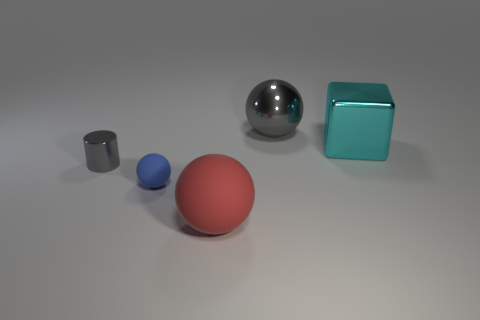The tiny shiny thing that is the same color as the large shiny sphere is what shape?
Your response must be concise. Cylinder. The tiny sphere is what color?
Your answer should be very brief. Blue. There is a gray metallic object on the left side of the red ball; how big is it?
Make the answer very short. Small. What number of cyan things are left of the large gray metallic ball that is to the right of the shiny cylinder to the left of the large cyan metal thing?
Your answer should be compact. 0. There is a object behind the large cyan metallic object right of the small matte sphere; what is its color?
Your answer should be compact. Gray. Is there a gray metal object that has the same size as the metallic cylinder?
Ensure brevity in your answer.  No. What is the material of the tiny object that is behind the small matte ball on the left side of the gray object that is to the right of the cylinder?
Keep it short and to the point. Metal. There is a big thing that is behind the cyan shiny thing; how many gray metal things are in front of it?
Your answer should be very brief. 1. There is a gray shiny thing left of the red rubber thing; is it the same size as the cyan block?
Your response must be concise. No. How many red objects are the same shape as the small blue matte object?
Offer a terse response. 1. 